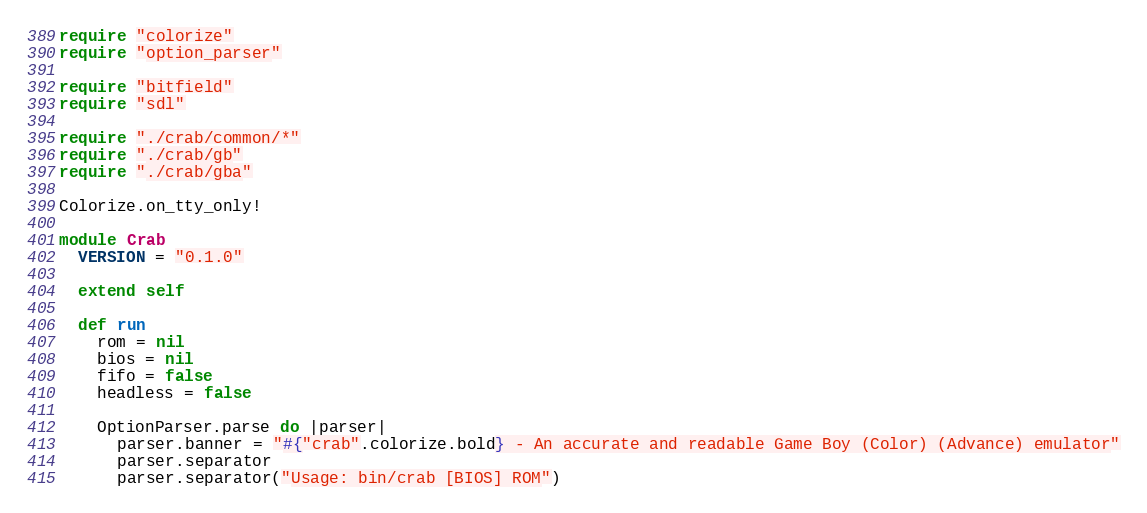Convert code to text. <code><loc_0><loc_0><loc_500><loc_500><_Crystal_>require "colorize"
require "option_parser"

require "bitfield"
require "sdl"

require "./crab/common/*"
require "./crab/gb"
require "./crab/gba"

Colorize.on_tty_only!

module Crab
  VERSION = "0.1.0"

  extend self

  def run
    rom = nil
    bios = nil
    fifo = false
    headless = false

    OptionParser.parse do |parser|
      parser.banner = "#{"crab".colorize.bold} - An accurate and readable Game Boy (Color) (Advance) emulator"
      parser.separator
      parser.separator("Usage: bin/crab [BIOS] ROM")</code> 